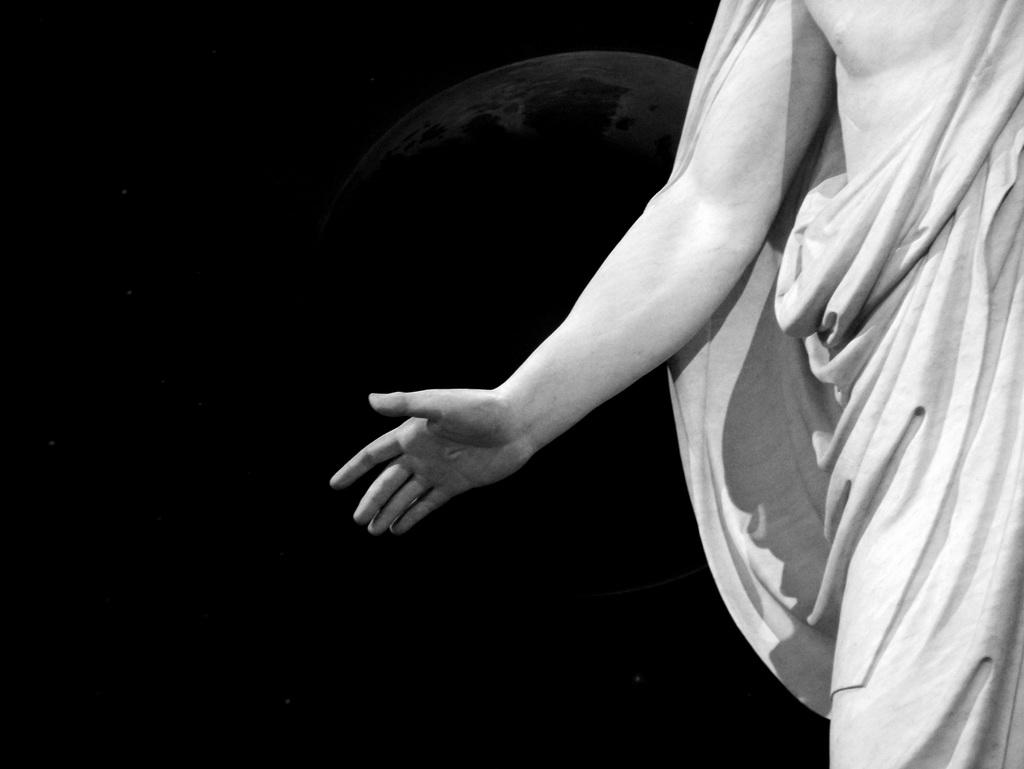What is the color scheme of the image? The image is black and white. Where is the man located in the image? The man is standing on the right side of the image. What is the man doing with his hands in the image? The man is trying to do something with his hands. What color is the background of the image? The background of the image is black in color. How many chickens can be seen in the image? There are no chickens present in the image. What type of snake is wrapped around the man's neck in the image? There is no snake present in the image. 